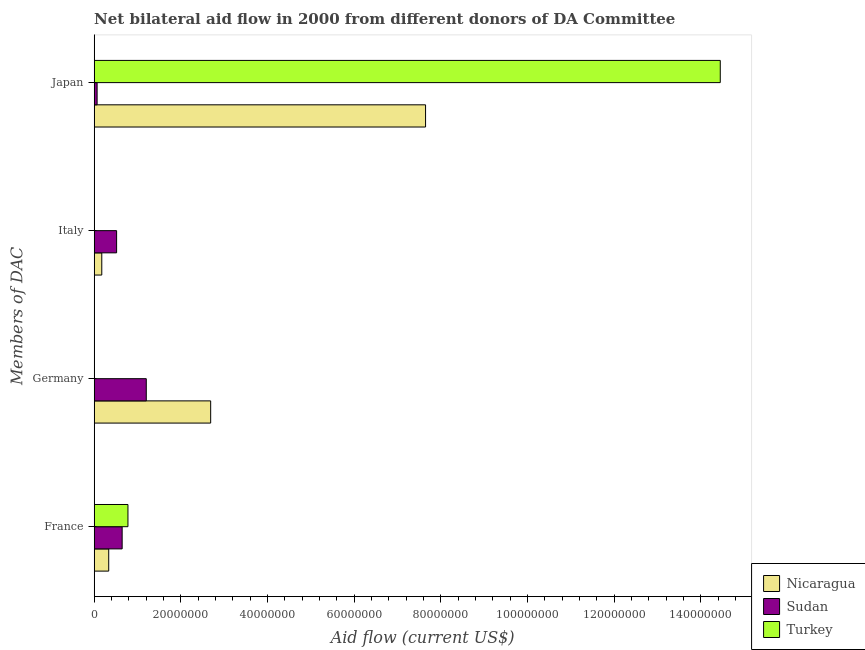How many different coloured bars are there?
Give a very brief answer. 3. What is the amount of aid given by france in Turkey?
Your answer should be compact. 7.79e+06. Across all countries, what is the maximum amount of aid given by germany?
Ensure brevity in your answer.  2.69e+07. Across all countries, what is the minimum amount of aid given by france?
Provide a succinct answer. 3.35e+06. In which country was the amount of aid given by france maximum?
Your answer should be compact. Turkey. What is the total amount of aid given by japan in the graph?
Your response must be concise. 2.22e+08. What is the difference between the amount of aid given by japan in Nicaragua and that in Turkey?
Your answer should be very brief. -6.80e+07. What is the difference between the amount of aid given by italy in Nicaragua and the amount of aid given by germany in Sudan?
Make the answer very short. -1.03e+07. What is the average amount of aid given by italy per country?
Provide a short and direct response. 2.31e+06. What is the difference between the amount of aid given by japan and amount of aid given by france in Nicaragua?
Offer a very short reply. 7.31e+07. What is the ratio of the amount of aid given by germany in Sudan to that in Nicaragua?
Provide a succinct answer. 0.45. What is the difference between the highest and the second highest amount of aid given by japan?
Your answer should be compact. 6.80e+07. What is the difference between the highest and the lowest amount of aid given by japan?
Keep it short and to the point. 1.44e+08. In how many countries, is the amount of aid given by italy greater than the average amount of aid given by italy taken over all countries?
Offer a terse response. 1. Is the sum of the amount of aid given by japan in Turkey and Sudan greater than the maximum amount of aid given by germany across all countries?
Give a very brief answer. Yes. How many countries are there in the graph?
Make the answer very short. 3. Where does the legend appear in the graph?
Offer a very short reply. Bottom right. What is the title of the graph?
Your answer should be compact. Net bilateral aid flow in 2000 from different donors of DA Committee. Does "Maldives" appear as one of the legend labels in the graph?
Your response must be concise. No. What is the label or title of the X-axis?
Offer a terse response. Aid flow (current US$). What is the label or title of the Y-axis?
Your answer should be very brief. Members of DAC. What is the Aid flow (current US$) of Nicaragua in France?
Offer a terse response. 3.35e+06. What is the Aid flow (current US$) in Sudan in France?
Your answer should be very brief. 6.45e+06. What is the Aid flow (current US$) in Turkey in France?
Make the answer very short. 7.79e+06. What is the Aid flow (current US$) of Nicaragua in Germany?
Keep it short and to the point. 2.69e+07. What is the Aid flow (current US$) in Sudan in Germany?
Ensure brevity in your answer.  1.20e+07. What is the Aid flow (current US$) in Nicaragua in Italy?
Offer a very short reply. 1.75e+06. What is the Aid flow (current US$) of Sudan in Italy?
Offer a very short reply. 5.17e+06. What is the Aid flow (current US$) of Turkey in Italy?
Provide a short and direct response. 0. What is the Aid flow (current US$) in Nicaragua in Japan?
Offer a very short reply. 7.65e+07. What is the Aid flow (current US$) in Sudan in Japan?
Your response must be concise. 6.70e+05. What is the Aid flow (current US$) of Turkey in Japan?
Ensure brevity in your answer.  1.44e+08. Across all Members of DAC, what is the maximum Aid flow (current US$) in Nicaragua?
Keep it short and to the point. 7.65e+07. Across all Members of DAC, what is the maximum Aid flow (current US$) in Sudan?
Give a very brief answer. 1.20e+07. Across all Members of DAC, what is the maximum Aid flow (current US$) of Turkey?
Provide a short and direct response. 1.44e+08. Across all Members of DAC, what is the minimum Aid flow (current US$) of Nicaragua?
Your response must be concise. 1.75e+06. Across all Members of DAC, what is the minimum Aid flow (current US$) in Sudan?
Make the answer very short. 6.70e+05. What is the total Aid flow (current US$) in Nicaragua in the graph?
Keep it short and to the point. 1.08e+08. What is the total Aid flow (current US$) of Sudan in the graph?
Keep it short and to the point. 2.43e+07. What is the total Aid flow (current US$) in Turkey in the graph?
Your answer should be very brief. 1.52e+08. What is the difference between the Aid flow (current US$) in Nicaragua in France and that in Germany?
Provide a succinct answer. -2.35e+07. What is the difference between the Aid flow (current US$) in Sudan in France and that in Germany?
Offer a very short reply. -5.57e+06. What is the difference between the Aid flow (current US$) of Nicaragua in France and that in Italy?
Ensure brevity in your answer.  1.60e+06. What is the difference between the Aid flow (current US$) in Sudan in France and that in Italy?
Offer a terse response. 1.28e+06. What is the difference between the Aid flow (current US$) in Nicaragua in France and that in Japan?
Offer a very short reply. -7.31e+07. What is the difference between the Aid flow (current US$) in Sudan in France and that in Japan?
Provide a short and direct response. 5.78e+06. What is the difference between the Aid flow (current US$) in Turkey in France and that in Japan?
Keep it short and to the point. -1.37e+08. What is the difference between the Aid flow (current US$) of Nicaragua in Germany and that in Italy?
Ensure brevity in your answer.  2.51e+07. What is the difference between the Aid flow (current US$) of Sudan in Germany and that in Italy?
Offer a very short reply. 6.85e+06. What is the difference between the Aid flow (current US$) in Nicaragua in Germany and that in Japan?
Your answer should be very brief. -4.96e+07. What is the difference between the Aid flow (current US$) of Sudan in Germany and that in Japan?
Provide a succinct answer. 1.14e+07. What is the difference between the Aid flow (current US$) of Nicaragua in Italy and that in Japan?
Give a very brief answer. -7.47e+07. What is the difference between the Aid flow (current US$) of Sudan in Italy and that in Japan?
Offer a terse response. 4.50e+06. What is the difference between the Aid flow (current US$) in Nicaragua in France and the Aid flow (current US$) in Sudan in Germany?
Give a very brief answer. -8.67e+06. What is the difference between the Aid flow (current US$) in Nicaragua in France and the Aid flow (current US$) in Sudan in Italy?
Make the answer very short. -1.82e+06. What is the difference between the Aid flow (current US$) in Nicaragua in France and the Aid flow (current US$) in Sudan in Japan?
Provide a short and direct response. 2.68e+06. What is the difference between the Aid flow (current US$) in Nicaragua in France and the Aid flow (current US$) in Turkey in Japan?
Provide a short and direct response. -1.41e+08. What is the difference between the Aid flow (current US$) in Sudan in France and the Aid flow (current US$) in Turkey in Japan?
Offer a very short reply. -1.38e+08. What is the difference between the Aid flow (current US$) of Nicaragua in Germany and the Aid flow (current US$) of Sudan in Italy?
Your answer should be very brief. 2.17e+07. What is the difference between the Aid flow (current US$) of Nicaragua in Germany and the Aid flow (current US$) of Sudan in Japan?
Your response must be concise. 2.62e+07. What is the difference between the Aid flow (current US$) of Nicaragua in Germany and the Aid flow (current US$) of Turkey in Japan?
Offer a terse response. -1.18e+08. What is the difference between the Aid flow (current US$) in Sudan in Germany and the Aid flow (current US$) in Turkey in Japan?
Your answer should be compact. -1.32e+08. What is the difference between the Aid flow (current US$) of Nicaragua in Italy and the Aid flow (current US$) of Sudan in Japan?
Your response must be concise. 1.08e+06. What is the difference between the Aid flow (current US$) in Nicaragua in Italy and the Aid flow (current US$) in Turkey in Japan?
Make the answer very short. -1.43e+08. What is the difference between the Aid flow (current US$) of Sudan in Italy and the Aid flow (current US$) of Turkey in Japan?
Provide a short and direct response. -1.39e+08. What is the average Aid flow (current US$) of Nicaragua per Members of DAC?
Make the answer very short. 2.71e+07. What is the average Aid flow (current US$) in Sudan per Members of DAC?
Offer a very short reply. 6.08e+06. What is the average Aid flow (current US$) of Turkey per Members of DAC?
Provide a short and direct response. 3.81e+07. What is the difference between the Aid flow (current US$) in Nicaragua and Aid flow (current US$) in Sudan in France?
Your response must be concise. -3.10e+06. What is the difference between the Aid flow (current US$) of Nicaragua and Aid flow (current US$) of Turkey in France?
Give a very brief answer. -4.44e+06. What is the difference between the Aid flow (current US$) of Sudan and Aid flow (current US$) of Turkey in France?
Your answer should be compact. -1.34e+06. What is the difference between the Aid flow (current US$) of Nicaragua and Aid flow (current US$) of Sudan in Germany?
Ensure brevity in your answer.  1.49e+07. What is the difference between the Aid flow (current US$) in Nicaragua and Aid flow (current US$) in Sudan in Italy?
Your answer should be very brief. -3.42e+06. What is the difference between the Aid flow (current US$) in Nicaragua and Aid flow (current US$) in Sudan in Japan?
Offer a terse response. 7.58e+07. What is the difference between the Aid flow (current US$) in Nicaragua and Aid flow (current US$) in Turkey in Japan?
Your response must be concise. -6.80e+07. What is the difference between the Aid flow (current US$) of Sudan and Aid flow (current US$) of Turkey in Japan?
Make the answer very short. -1.44e+08. What is the ratio of the Aid flow (current US$) of Nicaragua in France to that in Germany?
Give a very brief answer. 0.12. What is the ratio of the Aid flow (current US$) in Sudan in France to that in Germany?
Provide a short and direct response. 0.54. What is the ratio of the Aid flow (current US$) of Nicaragua in France to that in Italy?
Provide a succinct answer. 1.91. What is the ratio of the Aid flow (current US$) of Sudan in France to that in Italy?
Your answer should be compact. 1.25. What is the ratio of the Aid flow (current US$) of Nicaragua in France to that in Japan?
Your response must be concise. 0.04. What is the ratio of the Aid flow (current US$) of Sudan in France to that in Japan?
Your answer should be compact. 9.63. What is the ratio of the Aid flow (current US$) in Turkey in France to that in Japan?
Your answer should be compact. 0.05. What is the ratio of the Aid flow (current US$) in Nicaragua in Germany to that in Italy?
Your answer should be very brief. 15.36. What is the ratio of the Aid flow (current US$) of Sudan in Germany to that in Italy?
Make the answer very short. 2.33. What is the ratio of the Aid flow (current US$) of Nicaragua in Germany to that in Japan?
Offer a terse response. 0.35. What is the ratio of the Aid flow (current US$) of Sudan in Germany to that in Japan?
Offer a terse response. 17.94. What is the ratio of the Aid flow (current US$) in Nicaragua in Italy to that in Japan?
Your answer should be very brief. 0.02. What is the ratio of the Aid flow (current US$) in Sudan in Italy to that in Japan?
Your answer should be very brief. 7.72. What is the difference between the highest and the second highest Aid flow (current US$) of Nicaragua?
Your answer should be compact. 4.96e+07. What is the difference between the highest and the second highest Aid flow (current US$) of Sudan?
Your answer should be very brief. 5.57e+06. What is the difference between the highest and the lowest Aid flow (current US$) of Nicaragua?
Provide a succinct answer. 7.47e+07. What is the difference between the highest and the lowest Aid flow (current US$) of Sudan?
Give a very brief answer. 1.14e+07. What is the difference between the highest and the lowest Aid flow (current US$) in Turkey?
Ensure brevity in your answer.  1.44e+08. 